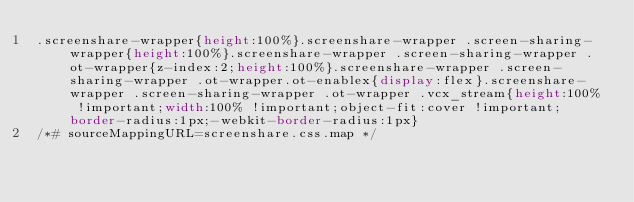Convert code to text. <code><loc_0><loc_0><loc_500><loc_500><_CSS_>.screenshare-wrapper{height:100%}.screenshare-wrapper .screen-sharing-wrapper{height:100%}.screenshare-wrapper .screen-sharing-wrapper .ot-wrapper{z-index:2;height:100%}.screenshare-wrapper .screen-sharing-wrapper .ot-wrapper.ot-enablex{display:flex}.screenshare-wrapper .screen-sharing-wrapper .ot-wrapper .vcx_stream{height:100% !important;width:100% !important;object-fit:cover !important;border-radius:1px;-webkit-border-radius:1px}
/*# sourceMappingURL=screenshare.css.map */
</code> 